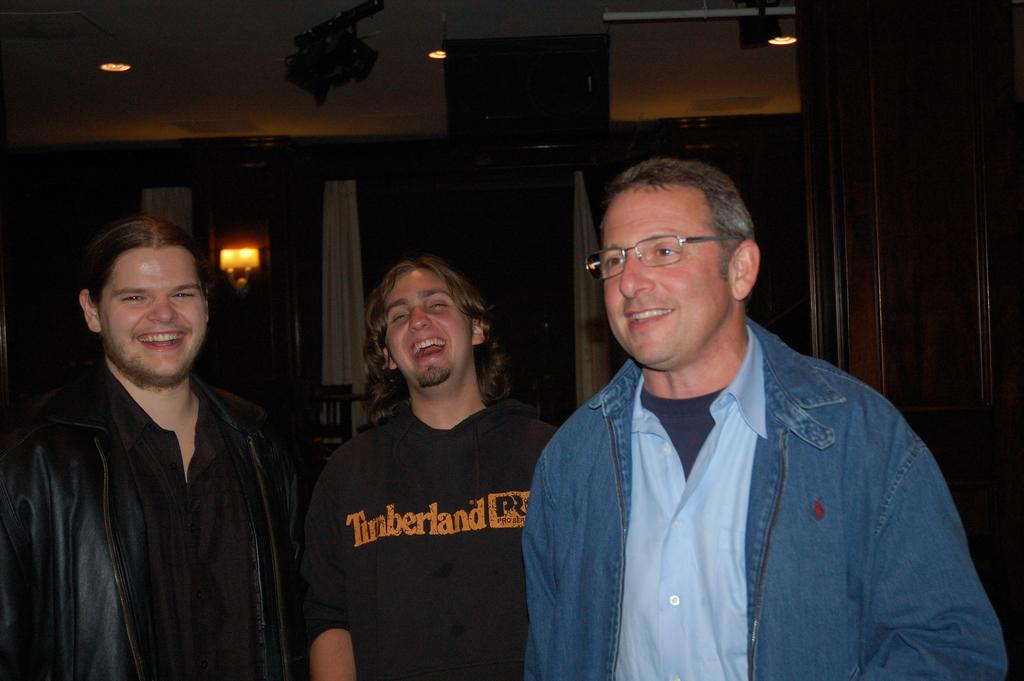Who or what can be seen in the image? There are people in the image. What can be observed in terms of lighting in the image? There are lights in the image. What type of window treatment is present in the image? There are curtains in the image. Can you describe any other objects present in the image? There are other objects present in the image, but their specific details are not mentioned in the provided facts. How does the jellyfish interact with the people in the image? There is no jellyfish present in the image, so it cannot interact with the people. 